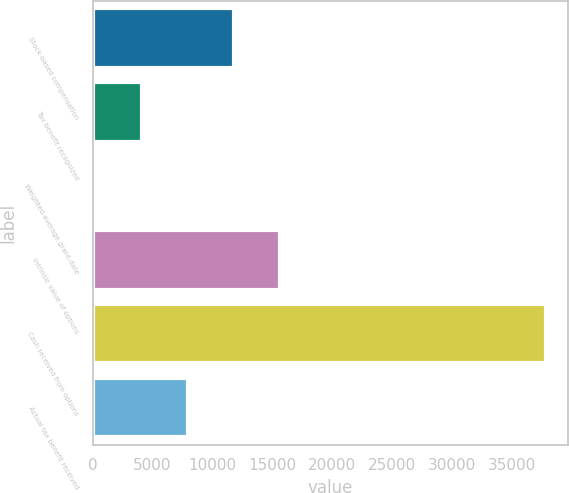Convert chart. <chart><loc_0><loc_0><loc_500><loc_500><bar_chart><fcel>Stock-based compensation<fcel>Tax benefit recognized<fcel>Weighted-average grant-date<fcel>Intrinsic value of options<fcel>Cash received from options<fcel>Actual tax benefit received<nl><fcel>11848<fcel>4147<fcel>10.35<fcel>15633.3<fcel>37863<fcel>7932.27<nl></chart> 